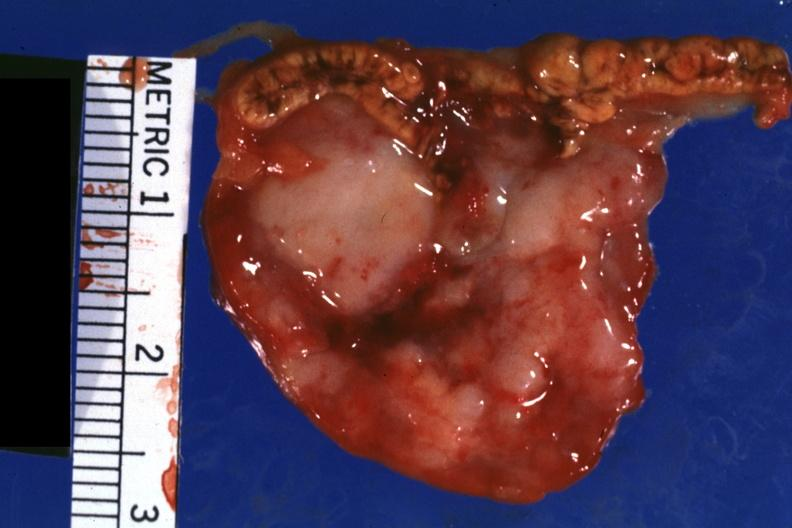does this image show close-up tumor is shown well?
Answer the question using a single word or phrase. Yes 